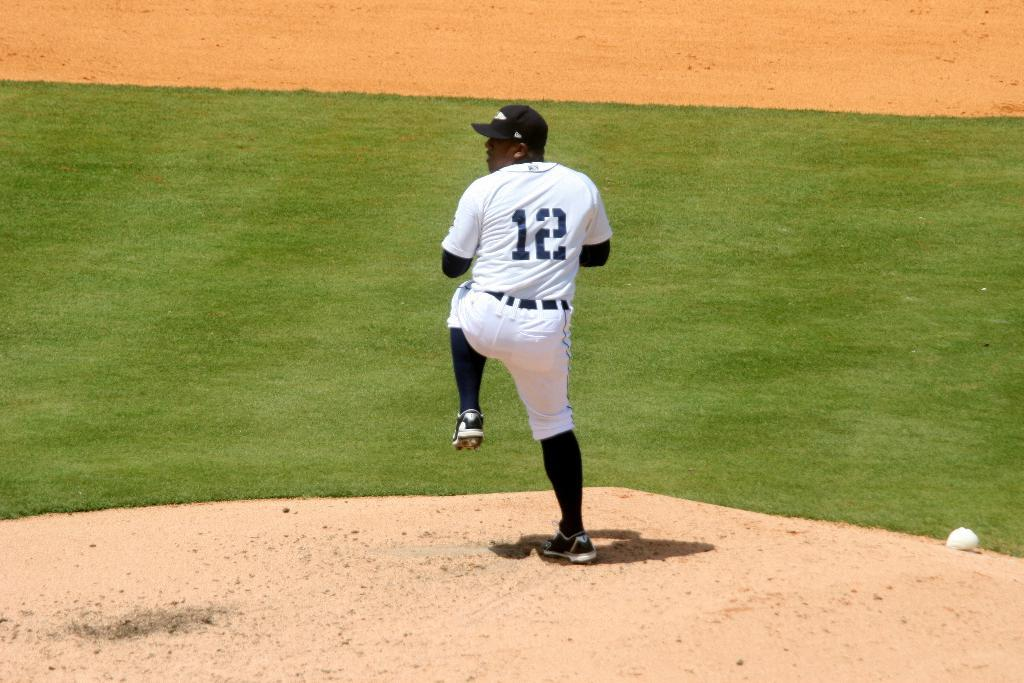<image>
Create a compact narrative representing the image presented. A baseball player is getting ready to throw a pitch and has a jersey with the number 12 on it. 